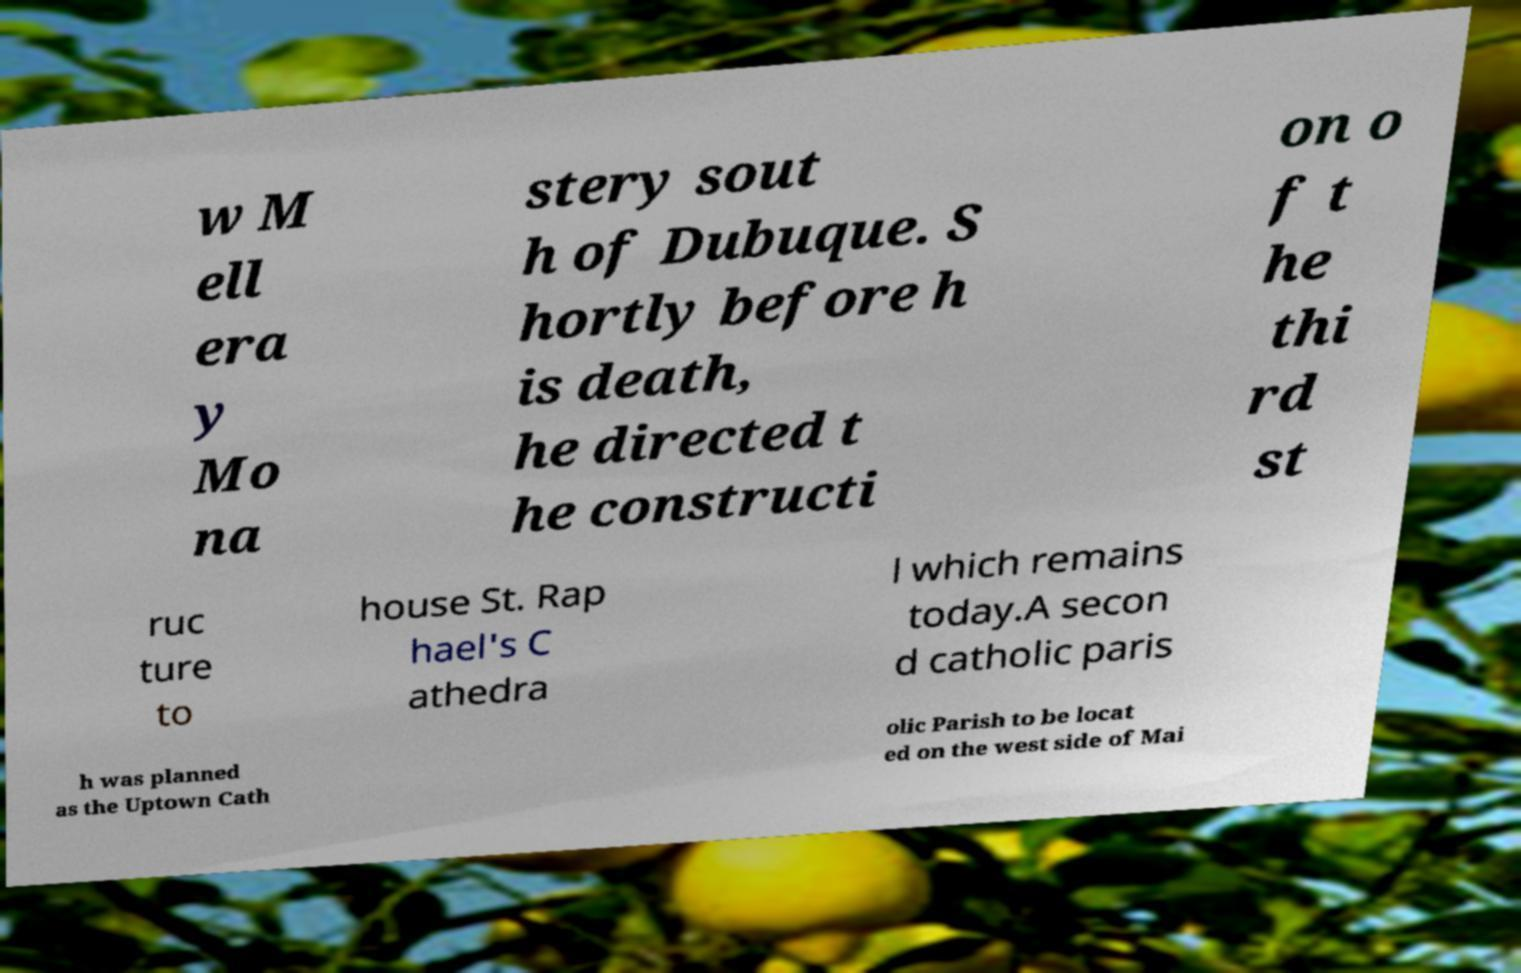Could you extract and type out the text from this image? w M ell era y Mo na stery sout h of Dubuque. S hortly before h is death, he directed t he constructi on o f t he thi rd st ruc ture to house St. Rap hael's C athedra l which remains today.A secon d catholic paris h was planned as the Uptown Cath olic Parish to be locat ed on the west side of Mai 